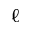<formula> <loc_0><loc_0><loc_500><loc_500>\ell</formula> 